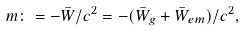<formula> <loc_0><loc_0><loc_500><loc_500>m \colon = - \bar { W } / c ^ { 2 } = - ( \bar { W } _ { g } + \bar { W } _ { e m } ) / c ^ { 2 } ,</formula> 